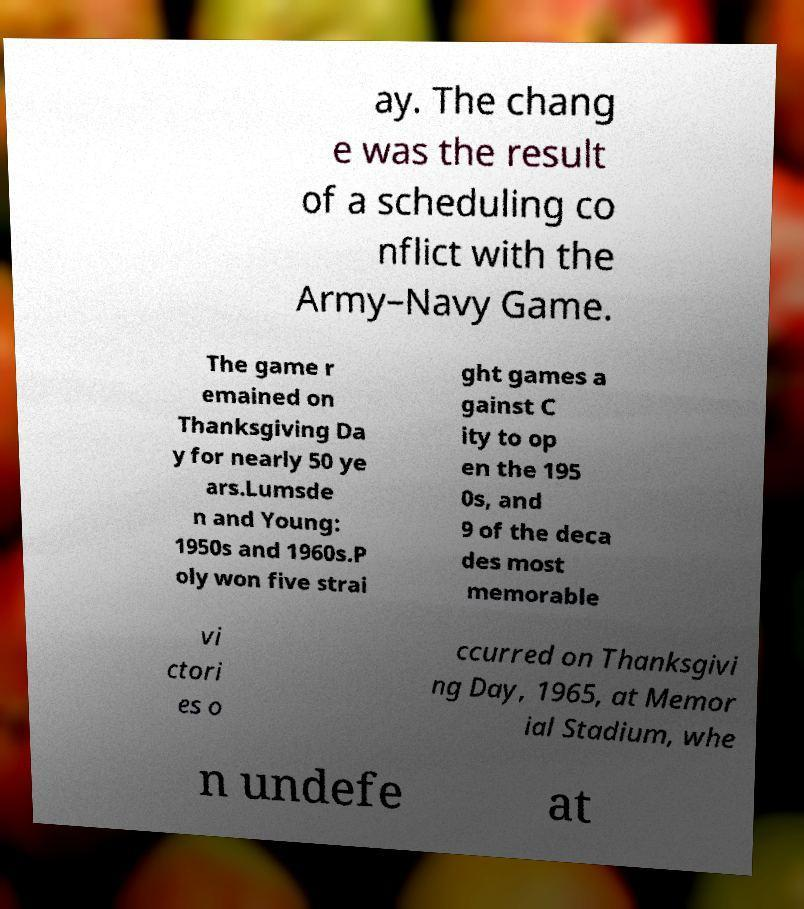I need the written content from this picture converted into text. Can you do that? ay. The chang e was the result of a scheduling co nflict with the Army–Navy Game. The game r emained on Thanksgiving Da y for nearly 50 ye ars.Lumsde n and Young: 1950s and 1960s.P oly won five strai ght games a gainst C ity to op en the 195 0s, and 9 of the deca des most memorable vi ctori es o ccurred on Thanksgivi ng Day, 1965, at Memor ial Stadium, whe n undefe at 